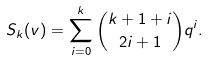<formula> <loc_0><loc_0><loc_500><loc_500>S _ { k } ( v ) = \sum _ { i = 0 } ^ { k } \binom { k + 1 + i } { 2 i + 1 } q ^ { i } .</formula> 